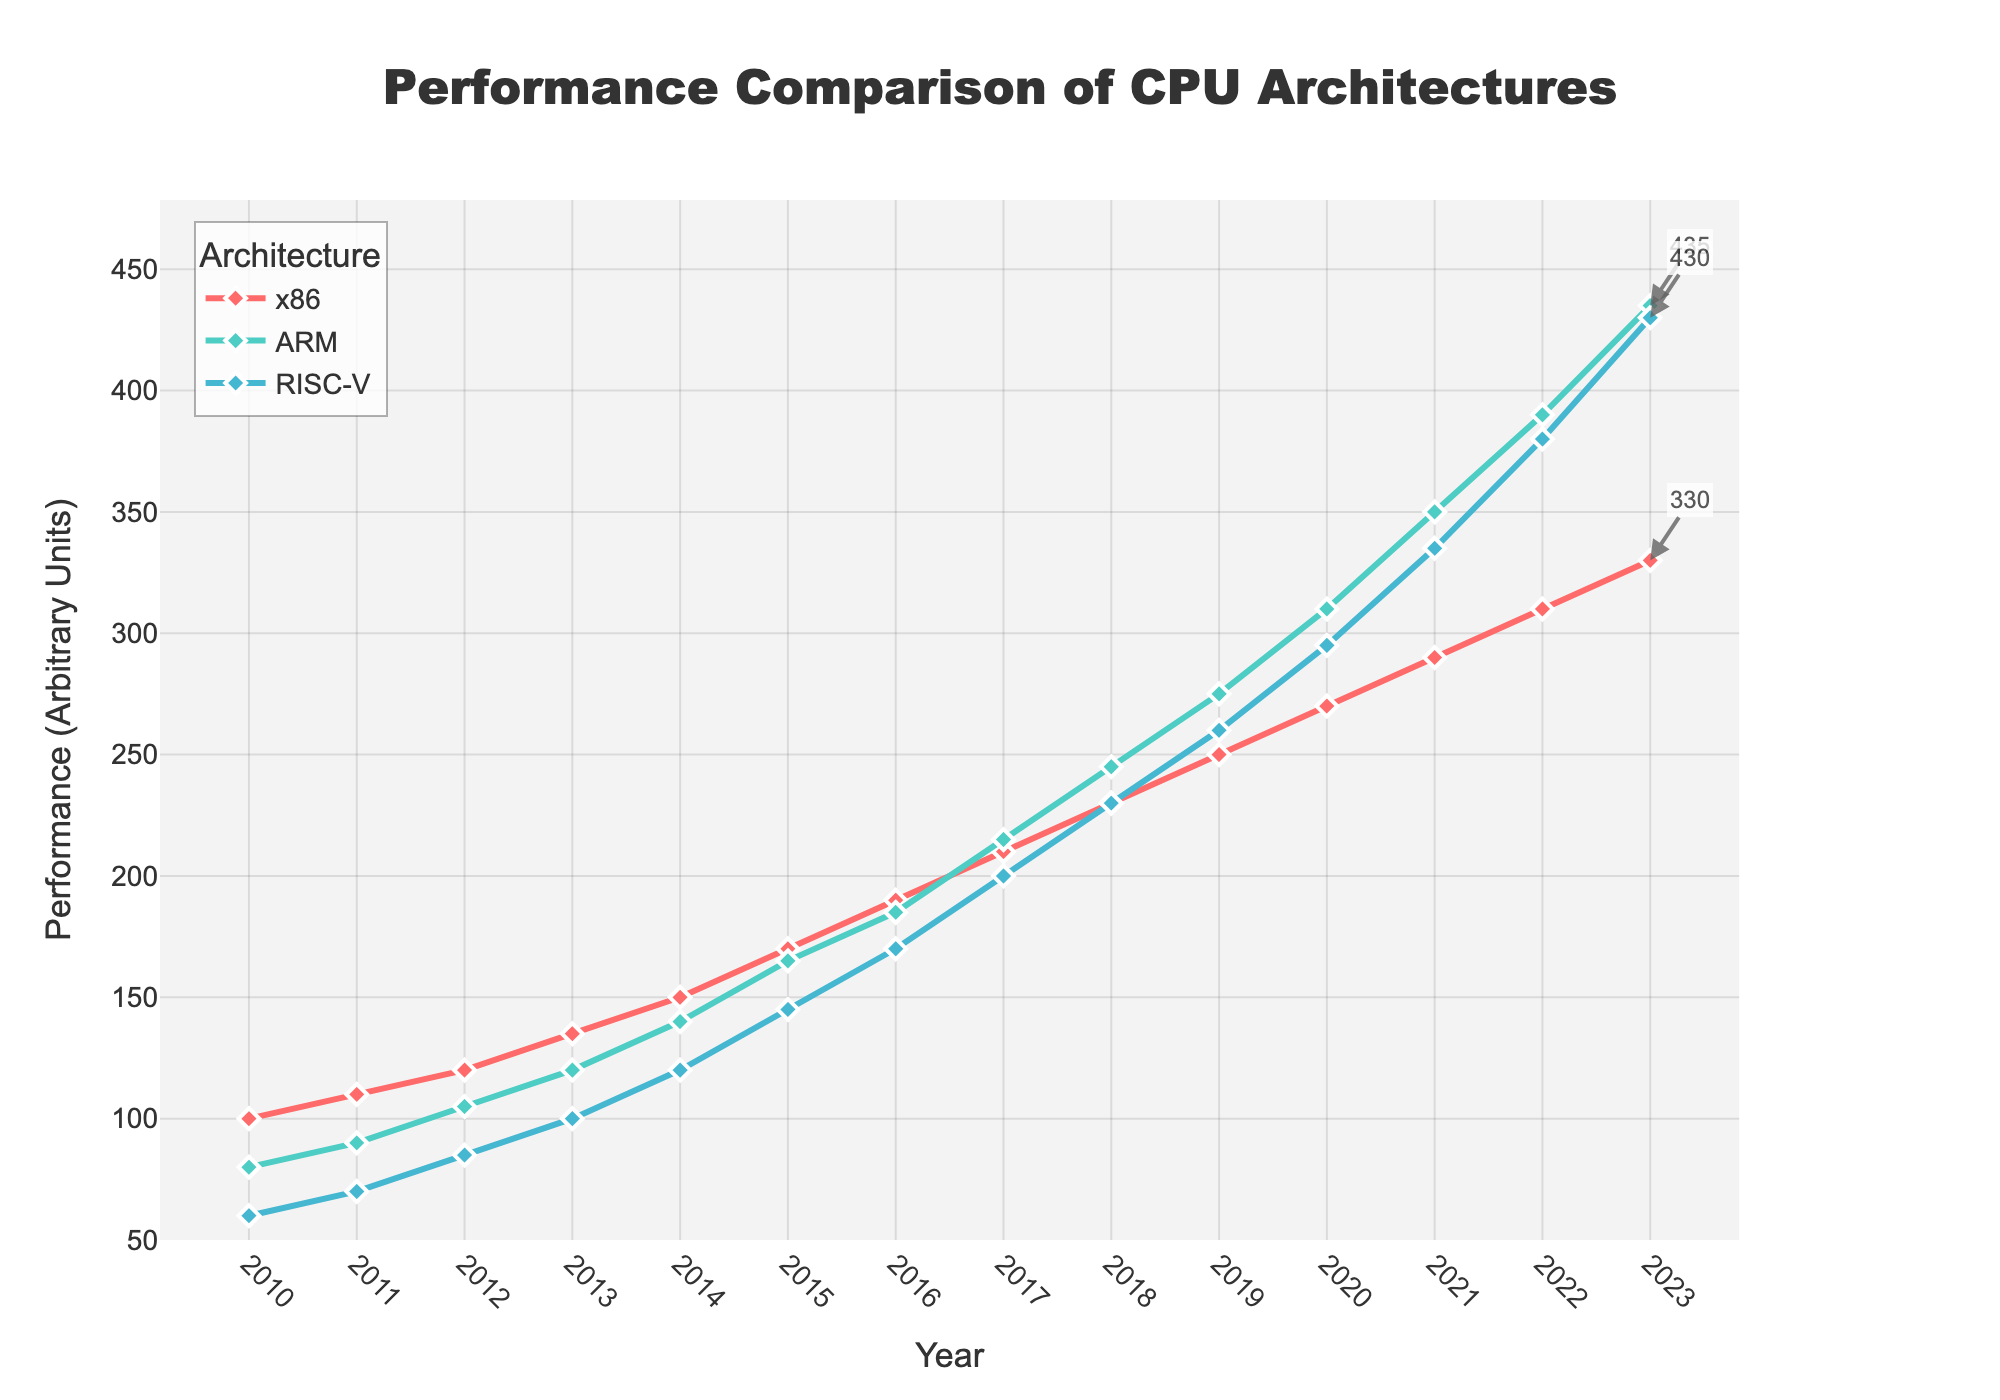Which CPU architecture had the highest performance in 2023? Check the performance values for x86, ARM, and RISC-V in 2023. ARM has the highest value at 435.
Answer: ARM Which CPU architecture showed the greatest performance increase between 2010 and 2023? Calculate the increase for each architecture from 2010 to 2023: x86 (330-100=230), ARM (435-80=355), RISC-V (430-60=370). The greatest increase is for RISC-V at 370.
Answer: RISC-V In which year did ARM's performance surpass both x86 and RISC-V performance? Look for the first year in the timeline where ARM's value is greater than both x86 and RISC-V. This first occurs in 2021.
Answer: 2021 What is the average performance of the x86 architecture over the entire period? Sum the x86 values: 100+110+120+135+150+170+190+210+230+250+270+290+310+330 = 2965. Divide by the number of years (14): 2965/14 = 211.79.
Answer: 211.79 By how much did RISC-V outperform x86 in 2023? Subtract x86 performance from RISC-V performance for 2023: 430 - 330 = 100.
Answer: 100 Which CPU architecture was the slowest to improve from 2010 to 2013? Calculate the performance increase from 2010 to 2013 for each architecture: x86 (135-100=35), ARM (120-80=40), RISC-V (100-60=40). x86 had the smallest increase of 35.
Answer: x86 In which year did x86's performance surpass 200? Identify the first year where x86's performance >200. This occurs in 2017.
Answer: 2017 How much did ARM's performance improve from 2015 to 2018? Find the values for ARM in 2015 and 2018 and calculate the difference: 245 - 165 = 80.
Answer: 80 What is the total performance improvement for all architectures combined from 2010 to 2023? Calculate the total performance in 2023 and 2010, then find the difference: (330+435+430) - (100+80+60) = 1195 - 240 = 955.
Answer: 955 